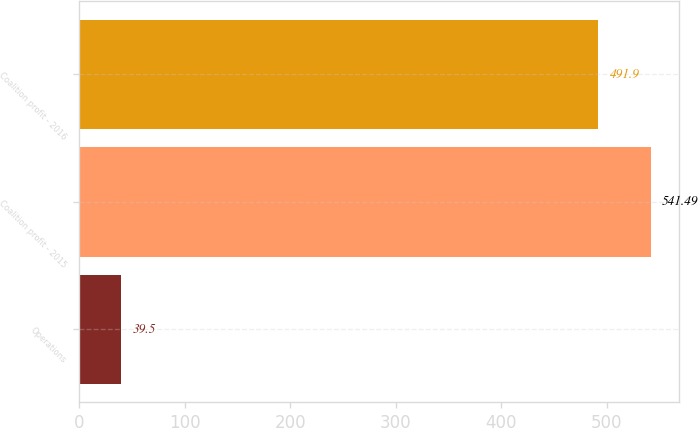Convert chart to OTSL. <chart><loc_0><loc_0><loc_500><loc_500><bar_chart><fcel>Operations<fcel>Coalition profit - 2015<fcel>Coalition profit - 2016<nl><fcel>39.5<fcel>541.49<fcel>491.9<nl></chart> 